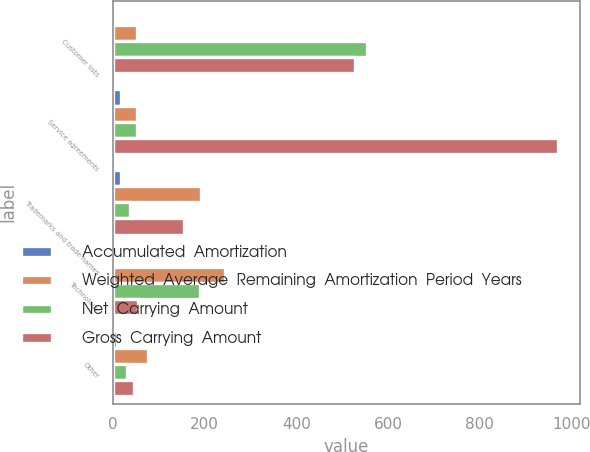<chart> <loc_0><loc_0><loc_500><loc_500><stacked_bar_chart><ecel><fcel>Customer lists<fcel>Service agreements<fcel>Trademarks and trade names<fcel>Technology<fcel>Other<nl><fcel>Accumulated  Amortization<fcel>7<fcel>18<fcel>18<fcel>4<fcel>8<nl><fcel>Weighted  Average  Remaining  Amortization  Period  Years<fcel>53<fcel>53<fcel>192<fcel>244<fcel>76<nl><fcel>Net  Carrying  Amount<fcel>554<fcel>52<fcel>38<fcel>190<fcel>31<nl><fcel>Gross  Carrying  Amount<fcel>527<fcel>970<fcel>154<fcel>54<fcel>45<nl></chart> 